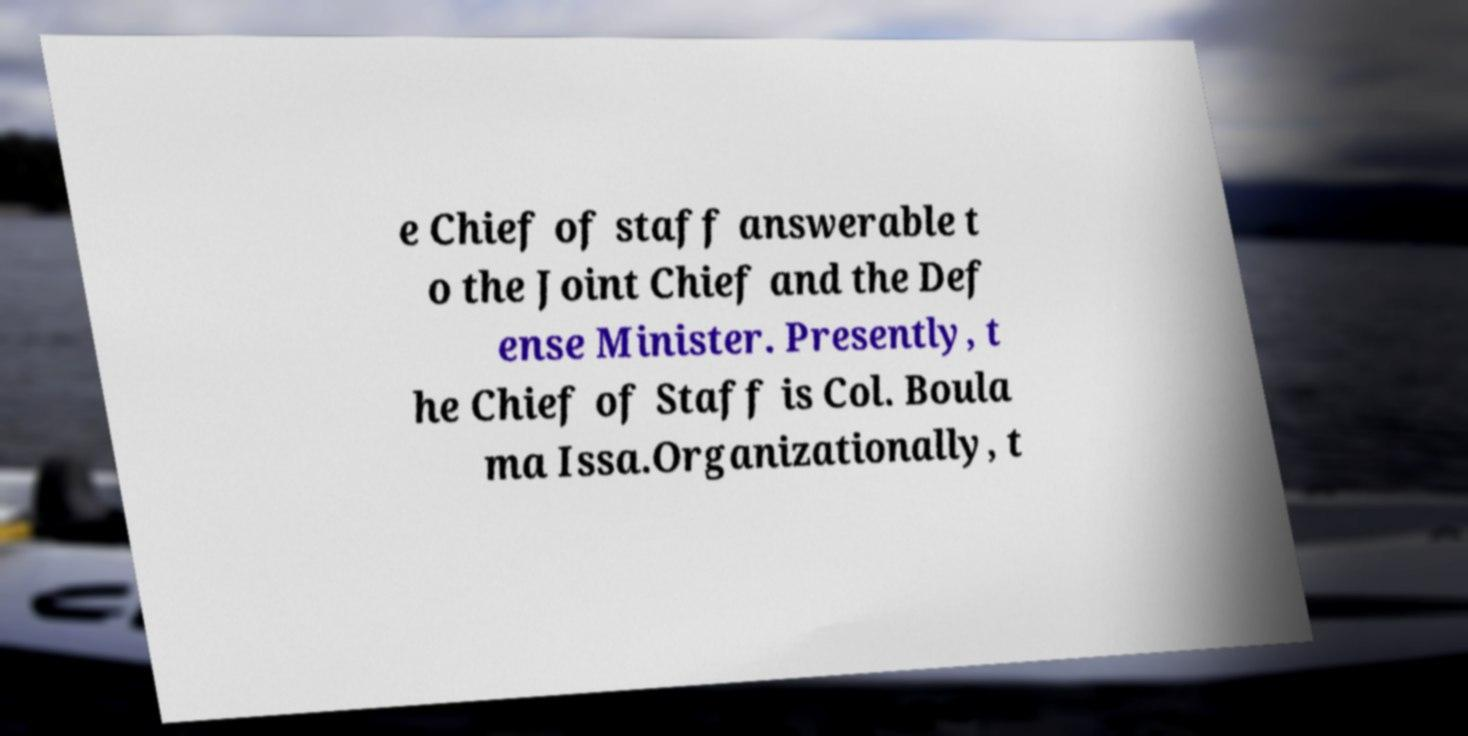For documentation purposes, I need the text within this image transcribed. Could you provide that? e Chief of staff answerable t o the Joint Chief and the Def ense Minister. Presently, t he Chief of Staff is Col. Boula ma Issa.Organizationally, t 